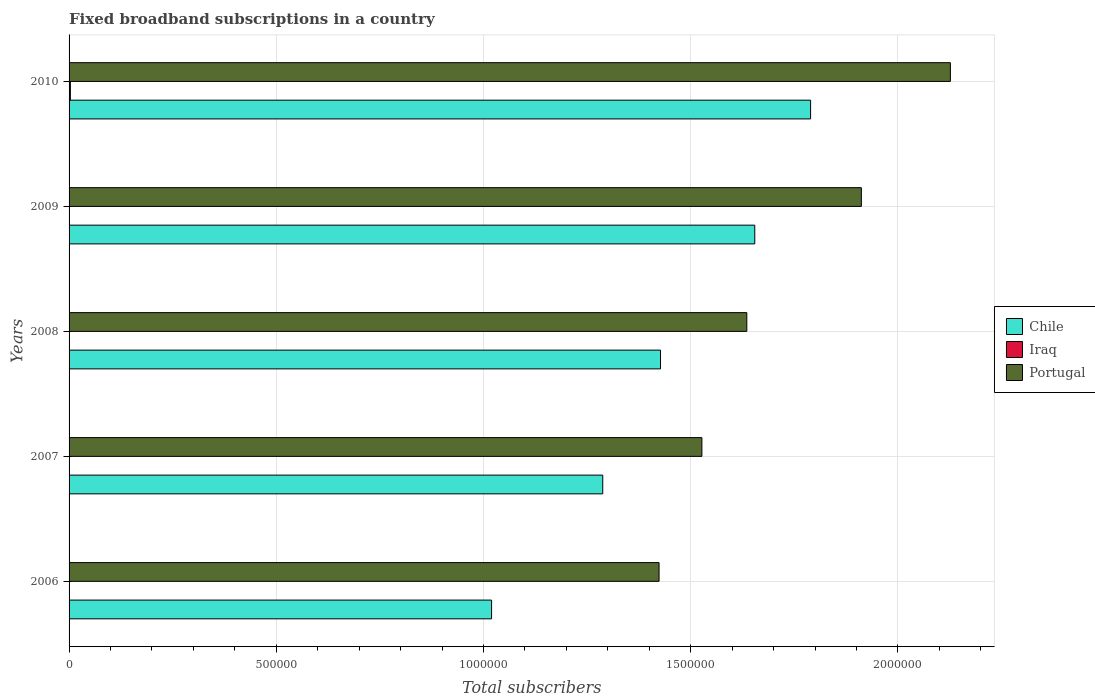Are the number of bars per tick equal to the number of legend labels?
Your answer should be compact. Yes. Are the number of bars on each tick of the Y-axis equal?
Your answer should be very brief. Yes. How many bars are there on the 3rd tick from the bottom?
Your answer should be compact. 3. What is the label of the 2nd group of bars from the top?
Ensure brevity in your answer.  2009. In how many cases, is the number of bars for a given year not equal to the number of legend labels?
Provide a succinct answer. 0. What is the number of broadband subscriptions in Chile in 2007?
Offer a terse response. 1.29e+06. Across all years, what is the maximum number of broadband subscriptions in Portugal?
Ensure brevity in your answer.  2.13e+06. Across all years, what is the minimum number of broadband subscriptions in Portugal?
Keep it short and to the point. 1.42e+06. What is the total number of broadband subscriptions in Chile in the graph?
Your answer should be compact. 7.18e+06. What is the difference between the number of broadband subscriptions in Chile in 2007 and that in 2008?
Give a very brief answer. -1.39e+05. What is the difference between the number of broadband subscriptions in Chile in 2006 and the number of broadband subscriptions in Iraq in 2007?
Offer a terse response. 1.02e+06. What is the average number of broadband subscriptions in Chile per year?
Your answer should be very brief. 1.44e+06. In the year 2010, what is the difference between the number of broadband subscriptions in Portugal and number of broadband subscriptions in Chile?
Provide a short and direct response. 3.37e+05. In how many years, is the number of broadband subscriptions in Chile greater than 1200000 ?
Your answer should be compact. 4. What is the ratio of the number of broadband subscriptions in Iraq in 2006 to that in 2008?
Make the answer very short. 0.48. Is the number of broadband subscriptions in Chile in 2007 less than that in 2010?
Offer a very short reply. Yes. Is the difference between the number of broadband subscriptions in Portugal in 2006 and 2008 greater than the difference between the number of broadband subscriptions in Chile in 2006 and 2008?
Provide a succinct answer. Yes. What is the difference between the highest and the second highest number of broadband subscriptions in Chile?
Ensure brevity in your answer.  1.35e+05. What is the difference between the highest and the lowest number of broadband subscriptions in Chile?
Ensure brevity in your answer.  7.70e+05. Is the sum of the number of broadband subscriptions in Chile in 2007 and 2009 greater than the maximum number of broadband subscriptions in Portugal across all years?
Ensure brevity in your answer.  Yes. What does the 2nd bar from the bottom in 2010 represents?
Give a very brief answer. Iraq. How many bars are there?
Keep it short and to the point. 15. Where does the legend appear in the graph?
Your answer should be very brief. Center right. How many legend labels are there?
Provide a short and direct response. 3. How are the legend labels stacked?
Provide a short and direct response. Vertical. What is the title of the graph?
Provide a short and direct response. Fixed broadband subscriptions in a country. What is the label or title of the X-axis?
Make the answer very short. Total subscribers. What is the label or title of the Y-axis?
Keep it short and to the point. Years. What is the Total subscribers in Chile in 2006?
Provide a short and direct response. 1.02e+06. What is the Total subscribers in Iraq in 2006?
Offer a terse response. 26. What is the Total subscribers of Portugal in 2006?
Ensure brevity in your answer.  1.42e+06. What is the Total subscribers in Chile in 2007?
Give a very brief answer. 1.29e+06. What is the Total subscribers in Iraq in 2007?
Offer a terse response. 98. What is the Total subscribers of Portugal in 2007?
Give a very brief answer. 1.53e+06. What is the Total subscribers in Chile in 2008?
Give a very brief answer. 1.43e+06. What is the Total subscribers in Iraq in 2008?
Provide a succinct answer. 54. What is the Total subscribers in Portugal in 2008?
Make the answer very short. 1.64e+06. What is the Total subscribers in Chile in 2009?
Offer a very short reply. 1.65e+06. What is the Total subscribers of Iraq in 2009?
Your answer should be very brief. 121. What is the Total subscribers in Portugal in 2009?
Your answer should be compact. 1.91e+06. What is the Total subscribers in Chile in 2010?
Ensure brevity in your answer.  1.79e+06. What is the Total subscribers of Iraq in 2010?
Make the answer very short. 3117. What is the Total subscribers in Portugal in 2010?
Keep it short and to the point. 2.13e+06. Across all years, what is the maximum Total subscribers in Chile?
Keep it short and to the point. 1.79e+06. Across all years, what is the maximum Total subscribers in Iraq?
Ensure brevity in your answer.  3117. Across all years, what is the maximum Total subscribers of Portugal?
Your response must be concise. 2.13e+06. Across all years, what is the minimum Total subscribers of Chile?
Your answer should be compact. 1.02e+06. Across all years, what is the minimum Total subscribers in Portugal?
Ensure brevity in your answer.  1.42e+06. What is the total Total subscribers of Chile in the graph?
Your answer should be very brief. 7.18e+06. What is the total Total subscribers in Iraq in the graph?
Provide a succinct answer. 3416. What is the total Total subscribers of Portugal in the graph?
Provide a short and direct response. 8.62e+06. What is the difference between the Total subscribers in Chile in 2006 and that in 2007?
Give a very brief answer. -2.68e+05. What is the difference between the Total subscribers of Iraq in 2006 and that in 2007?
Offer a terse response. -72. What is the difference between the Total subscribers of Portugal in 2006 and that in 2007?
Make the answer very short. -1.03e+05. What is the difference between the Total subscribers of Chile in 2006 and that in 2008?
Your answer should be compact. -4.08e+05. What is the difference between the Total subscribers in Portugal in 2006 and that in 2008?
Ensure brevity in your answer.  -2.12e+05. What is the difference between the Total subscribers in Chile in 2006 and that in 2009?
Provide a succinct answer. -6.35e+05. What is the difference between the Total subscribers in Iraq in 2006 and that in 2009?
Ensure brevity in your answer.  -95. What is the difference between the Total subscribers in Portugal in 2006 and that in 2009?
Offer a very short reply. -4.88e+05. What is the difference between the Total subscribers in Chile in 2006 and that in 2010?
Give a very brief answer. -7.70e+05. What is the difference between the Total subscribers in Iraq in 2006 and that in 2010?
Ensure brevity in your answer.  -3091. What is the difference between the Total subscribers in Portugal in 2006 and that in 2010?
Make the answer very short. -7.03e+05. What is the difference between the Total subscribers in Chile in 2007 and that in 2008?
Provide a succinct answer. -1.39e+05. What is the difference between the Total subscribers in Portugal in 2007 and that in 2008?
Your answer should be compact. -1.08e+05. What is the difference between the Total subscribers in Chile in 2007 and that in 2009?
Provide a succinct answer. -3.67e+05. What is the difference between the Total subscribers of Portugal in 2007 and that in 2009?
Keep it short and to the point. -3.85e+05. What is the difference between the Total subscribers in Chile in 2007 and that in 2010?
Ensure brevity in your answer.  -5.02e+05. What is the difference between the Total subscribers in Iraq in 2007 and that in 2010?
Your answer should be very brief. -3019. What is the difference between the Total subscribers of Portugal in 2007 and that in 2010?
Give a very brief answer. -6.00e+05. What is the difference between the Total subscribers of Chile in 2008 and that in 2009?
Offer a very short reply. -2.27e+05. What is the difference between the Total subscribers in Iraq in 2008 and that in 2009?
Provide a succinct answer. -67. What is the difference between the Total subscribers of Portugal in 2008 and that in 2009?
Your answer should be very brief. -2.76e+05. What is the difference between the Total subscribers of Chile in 2008 and that in 2010?
Provide a short and direct response. -3.62e+05. What is the difference between the Total subscribers in Iraq in 2008 and that in 2010?
Offer a very short reply. -3063. What is the difference between the Total subscribers in Portugal in 2008 and that in 2010?
Offer a very short reply. -4.91e+05. What is the difference between the Total subscribers in Chile in 2009 and that in 2010?
Give a very brief answer. -1.35e+05. What is the difference between the Total subscribers of Iraq in 2009 and that in 2010?
Offer a terse response. -2996. What is the difference between the Total subscribers in Portugal in 2009 and that in 2010?
Give a very brief answer. -2.15e+05. What is the difference between the Total subscribers of Chile in 2006 and the Total subscribers of Iraq in 2007?
Your answer should be compact. 1.02e+06. What is the difference between the Total subscribers of Chile in 2006 and the Total subscribers of Portugal in 2007?
Your answer should be very brief. -5.08e+05. What is the difference between the Total subscribers of Iraq in 2006 and the Total subscribers of Portugal in 2007?
Keep it short and to the point. -1.53e+06. What is the difference between the Total subscribers of Chile in 2006 and the Total subscribers of Iraq in 2008?
Provide a succinct answer. 1.02e+06. What is the difference between the Total subscribers of Chile in 2006 and the Total subscribers of Portugal in 2008?
Your response must be concise. -6.16e+05. What is the difference between the Total subscribers in Iraq in 2006 and the Total subscribers in Portugal in 2008?
Give a very brief answer. -1.64e+06. What is the difference between the Total subscribers of Chile in 2006 and the Total subscribers of Iraq in 2009?
Your response must be concise. 1.02e+06. What is the difference between the Total subscribers of Chile in 2006 and the Total subscribers of Portugal in 2009?
Your response must be concise. -8.92e+05. What is the difference between the Total subscribers of Iraq in 2006 and the Total subscribers of Portugal in 2009?
Provide a succinct answer. -1.91e+06. What is the difference between the Total subscribers of Chile in 2006 and the Total subscribers of Iraq in 2010?
Provide a succinct answer. 1.02e+06. What is the difference between the Total subscribers in Chile in 2006 and the Total subscribers in Portugal in 2010?
Provide a succinct answer. -1.11e+06. What is the difference between the Total subscribers of Iraq in 2006 and the Total subscribers of Portugal in 2010?
Ensure brevity in your answer.  -2.13e+06. What is the difference between the Total subscribers of Chile in 2007 and the Total subscribers of Iraq in 2008?
Give a very brief answer. 1.29e+06. What is the difference between the Total subscribers in Chile in 2007 and the Total subscribers in Portugal in 2008?
Give a very brief answer. -3.48e+05. What is the difference between the Total subscribers of Iraq in 2007 and the Total subscribers of Portugal in 2008?
Ensure brevity in your answer.  -1.64e+06. What is the difference between the Total subscribers in Chile in 2007 and the Total subscribers in Iraq in 2009?
Give a very brief answer. 1.29e+06. What is the difference between the Total subscribers of Chile in 2007 and the Total subscribers of Portugal in 2009?
Keep it short and to the point. -6.24e+05. What is the difference between the Total subscribers of Iraq in 2007 and the Total subscribers of Portugal in 2009?
Your answer should be compact. -1.91e+06. What is the difference between the Total subscribers in Chile in 2007 and the Total subscribers in Iraq in 2010?
Ensure brevity in your answer.  1.28e+06. What is the difference between the Total subscribers in Chile in 2007 and the Total subscribers in Portugal in 2010?
Your answer should be very brief. -8.39e+05. What is the difference between the Total subscribers of Iraq in 2007 and the Total subscribers of Portugal in 2010?
Make the answer very short. -2.13e+06. What is the difference between the Total subscribers of Chile in 2008 and the Total subscribers of Iraq in 2009?
Keep it short and to the point. 1.43e+06. What is the difference between the Total subscribers in Chile in 2008 and the Total subscribers in Portugal in 2009?
Make the answer very short. -4.85e+05. What is the difference between the Total subscribers in Iraq in 2008 and the Total subscribers in Portugal in 2009?
Make the answer very short. -1.91e+06. What is the difference between the Total subscribers in Chile in 2008 and the Total subscribers in Iraq in 2010?
Provide a succinct answer. 1.42e+06. What is the difference between the Total subscribers of Chile in 2008 and the Total subscribers of Portugal in 2010?
Keep it short and to the point. -7.00e+05. What is the difference between the Total subscribers of Iraq in 2008 and the Total subscribers of Portugal in 2010?
Provide a short and direct response. -2.13e+06. What is the difference between the Total subscribers in Chile in 2009 and the Total subscribers in Iraq in 2010?
Your answer should be compact. 1.65e+06. What is the difference between the Total subscribers of Chile in 2009 and the Total subscribers of Portugal in 2010?
Your answer should be very brief. -4.72e+05. What is the difference between the Total subscribers of Iraq in 2009 and the Total subscribers of Portugal in 2010?
Ensure brevity in your answer.  -2.13e+06. What is the average Total subscribers in Chile per year?
Make the answer very short. 1.44e+06. What is the average Total subscribers in Iraq per year?
Your response must be concise. 683.2. What is the average Total subscribers in Portugal per year?
Your answer should be compact. 1.72e+06. In the year 2006, what is the difference between the Total subscribers in Chile and Total subscribers in Iraq?
Provide a short and direct response. 1.02e+06. In the year 2006, what is the difference between the Total subscribers of Chile and Total subscribers of Portugal?
Ensure brevity in your answer.  -4.04e+05. In the year 2006, what is the difference between the Total subscribers of Iraq and Total subscribers of Portugal?
Offer a terse response. -1.42e+06. In the year 2007, what is the difference between the Total subscribers of Chile and Total subscribers of Iraq?
Offer a terse response. 1.29e+06. In the year 2007, what is the difference between the Total subscribers in Chile and Total subscribers in Portugal?
Provide a short and direct response. -2.39e+05. In the year 2007, what is the difference between the Total subscribers of Iraq and Total subscribers of Portugal?
Give a very brief answer. -1.53e+06. In the year 2008, what is the difference between the Total subscribers in Chile and Total subscribers in Iraq?
Provide a succinct answer. 1.43e+06. In the year 2008, what is the difference between the Total subscribers in Chile and Total subscribers in Portugal?
Ensure brevity in your answer.  -2.08e+05. In the year 2008, what is the difference between the Total subscribers in Iraq and Total subscribers in Portugal?
Offer a terse response. -1.64e+06. In the year 2009, what is the difference between the Total subscribers of Chile and Total subscribers of Iraq?
Keep it short and to the point. 1.65e+06. In the year 2009, what is the difference between the Total subscribers of Chile and Total subscribers of Portugal?
Your answer should be very brief. -2.57e+05. In the year 2009, what is the difference between the Total subscribers of Iraq and Total subscribers of Portugal?
Provide a short and direct response. -1.91e+06. In the year 2010, what is the difference between the Total subscribers in Chile and Total subscribers in Iraq?
Make the answer very short. 1.79e+06. In the year 2010, what is the difference between the Total subscribers of Chile and Total subscribers of Portugal?
Provide a succinct answer. -3.37e+05. In the year 2010, what is the difference between the Total subscribers of Iraq and Total subscribers of Portugal?
Your answer should be compact. -2.12e+06. What is the ratio of the Total subscribers in Chile in 2006 to that in 2007?
Make the answer very short. 0.79. What is the ratio of the Total subscribers in Iraq in 2006 to that in 2007?
Offer a very short reply. 0.27. What is the ratio of the Total subscribers in Portugal in 2006 to that in 2007?
Ensure brevity in your answer.  0.93. What is the ratio of the Total subscribers of Chile in 2006 to that in 2008?
Provide a succinct answer. 0.71. What is the ratio of the Total subscribers in Iraq in 2006 to that in 2008?
Your answer should be very brief. 0.48. What is the ratio of the Total subscribers in Portugal in 2006 to that in 2008?
Your answer should be compact. 0.87. What is the ratio of the Total subscribers in Chile in 2006 to that in 2009?
Make the answer very short. 0.62. What is the ratio of the Total subscribers of Iraq in 2006 to that in 2009?
Provide a succinct answer. 0.21. What is the ratio of the Total subscribers of Portugal in 2006 to that in 2009?
Your answer should be very brief. 0.74. What is the ratio of the Total subscribers of Chile in 2006 to that in 2010?
Your answer should be compact. 0.57. What is the ratio of the Total subscribers in Iraq in 2006 to that in 2010?
Your answer should be very brief. 0.01. What is the ratio of the Total subscribers in Portugal in 2006 to that in 2010?
Your answer should be very brief. 0.67. What is the ratio of the Total subscribers of Chile in 2007 to that in 2008?
Your answer should be compact. 0.9. What is the ratio of the Total subscribers of Iraq in 2007 to that in 2008?
Ensure brevity in your answer.  1.81. What is the ratio of the Total subscribers of Portugal in 2007 to that in 2008?
Your answer should be compact. 0.93. What is the ratio of the Total subscribers in Chile in 2007 to that in 2009?
Give a very brief answer. 0.78. What is the ratio of the Total subscribers of Iraq in 2007 to that in 2009?
Ensure brevity in your answer.  0.81. What is the ratio of the Total subscribers in Portugal in 2007 to that in 2009?
Ensure brevity in your answer.  0.8. What is the ratio of the Total subscribers in Chile in 2007 to that in 2010?
Your answer should be very brief. 0.72. What is the ratio of the Total subscribers of Iraq in 2007 to that in 2010?
Keep it short and to the point. 0.03. What is the ratio of the Total subscribers of Portugal in 2007 to that in 2010?
Make the answer very short. 0.72. What is the ratio of the Total subscribers of Chile in 2008 to that in 2009?
Offer a terse response. 0.86. What is the ratio of the Total subscribers in Iraq in 2008 to that in 2009?
Offer a terse response. 0.45. What is the ratio of the Total subscribers in Portugal in 2008 to that in 2009?
Offer a terse response. 0.86. What is the ratio of the Total subscribers in Chile in 2008 to that in 2010?
Offer a terse response. 0.8. What is the ratio of the Total subscribers of Iraq in 2008 to that in 2010?
Offer a terse response. 0.02. What is the ratio of the Total subscribers in Portugal in 2008 to that in 2010?
Offer a very short reply. 0.77. What is the ratio of the Total subscribers of Chile in 2009 to that in 2010?
Keep it short and to the point. 0.92. What is the ratio of the Total subscribers in Iraq in 2009 to that in 2010?
Give a very brief answer. 0.04. What is the ratio of the Total subscribers of Portugal in 2009 to that in 2010?
Give a very brief answer. 0.9. What is the difference between the highest and the second highest Total subscribers in Chile?
Give a very brief answer. 1.35e+05. What is the difference between the highest and the second highest Total subscribers of Iraq?
Ensure brevity in your answer.  2996. What is the difference between the highest and the second highest Total subscribers of Portugal?
Your answer should be very brief. 2.15e+05. What is the difference between the highest and the lowest Total subscribers in Chile?
Offer a terse response. 7.70e+05. What is the difference between the highest and the lowest Total subscribers in Iraq?
Offer a terse response. 3091. What is the difference between the highest and the lowest Total subscribers of Portugal?
Your answer should be compact. 7.03e+05. 